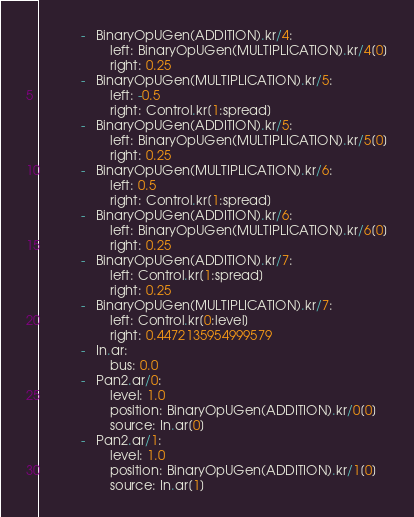Convert code to text. <code><loc_0><loc_0><loc_500><loc_500><_Python_>            -   BinaryOpUGen(ADDITION).kr/4:
                    left: BinaryOpUGen(MULTIPLICATION).kr/4[0]
                    right: 0.25
            -   BinaryOpUGen(MULTIPLICATION).kr/5:
                    left: -0.5
                    right: Control.kr[1:spread]
            -   BinaryOpUGen(ADDITION).kr/5:
                    left: BinaryOpUGen(MULTIPLICATION).kr/5[0]
                    right: 0.25
            -   BinaryOpUGen(MULTIPLICATION).kr/6:
                    left: 0.5
                    right: Control.kr[1:spread]
            -   BinaryOpUGen(ADDITION).kr/6:
                    left: BinaryOpUGen(MULTIPLICATION).kr/6[0]
                    right: 0.25
            -   BinaryOpUGen(ADDITION).kr/7:
                    left: Control.kr[1:spread]
                    right: 0.25
            -   BinaryOpUGen(MULTIPLICATION).kr/7:
                    left: Control.kr[0:level]
                    right: 0.4472135954999579
            -   In.ar:
                    bus: 0.0
            -   Pan2.ar/0:
                    level: 1.0
                    position: BinaryOpUGen(ADDITION).kr/0[0]
                    source: In.ar[0]
            -   Pan2.ar/1:
                    level: 1.0
                    position: BinaryOpUGen(ADDITION).kr/1[0]
                    source: In.ar[1]</code> 